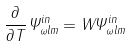<formula> <loc_0><loc_0><loc_500><loc_500>\frac { \partial } { \partial T } \Psi _ { \omega l m } ^ { i n } = W \Psi _ { \omega l m } ^ { i n }</formula> 